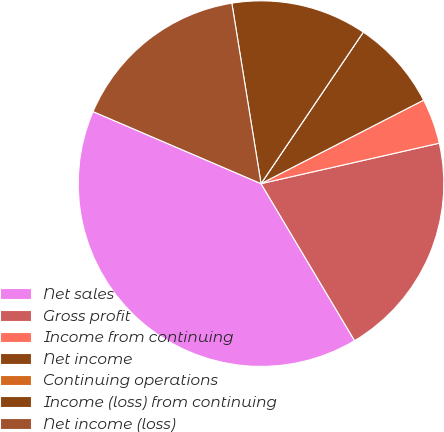Convert chart. <chart><loc_0><loc_0><loc_500><loc_500><pie_chart><fcel>Net sales<fcel>Gross profit<fcel>Income from continuing<fcel>Net income<fcel>Continuing operations<fcel>Income (loss) from continuing<fcel>Net income (loss)<nl><fcel>40.0%<fcel>20.0%<fcel>4.0%<fcel>8.0%<fcel>0.0%<fcel>12.0%<fcel>16.0%<nl></chart> 